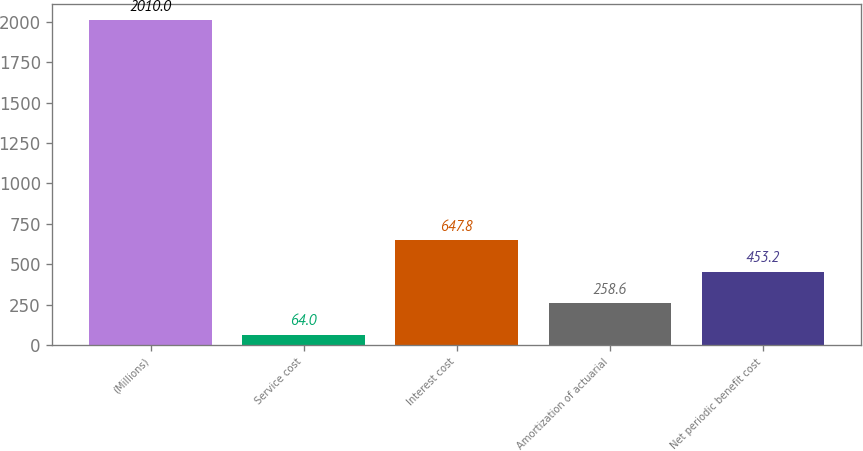Convert chart to OTSL. <chart><loc_0><loc_0><loc_500><loc_500><bar_chart><fcel>(Millions)<fcel>Service cost<fcel>Interest cost<fcel>Amortization of actuarial<fcel>Net periodic benefit cost<nl><fcel>2010<fcel>64<fcel>647.8<fcel>258.6<fcel>453.2<nl></chart> 